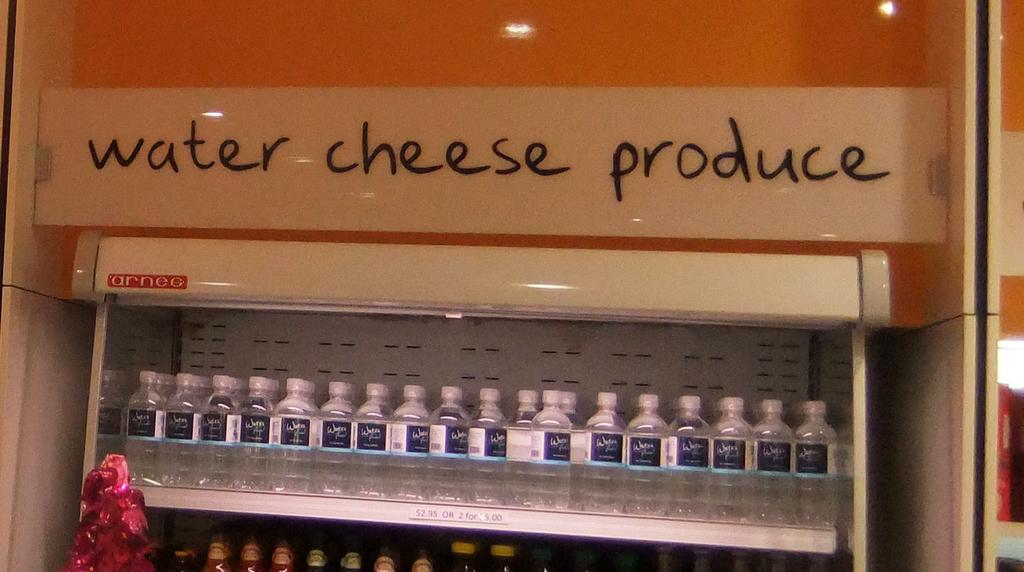What objects are present in large quantities in the image? There are many bottles in the image. Where are the bottles located? The bottles are kept on a shelf. What else can be seen in the image besides the bottles? There is text visible in the image. How many cattle can be seen grazing in the image? There are no cattle present in the image; it features many bottles on a shelf with visible text. What type of bread is being sliced in the image? There is no bread present in the image. 